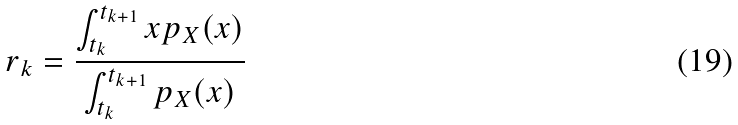Convert formula to latex. <formula><loc_0><loc_0><loc_500><loc_500>r _ { k } = \frac { \int _ { t _ { k } } ^ { t _ { k + 1 } } x p _ { X } ( x ) } { \int _ { t _ { k } } ^ { t _ { k + 1 } } p _ { X } ( x ) }</formula> 